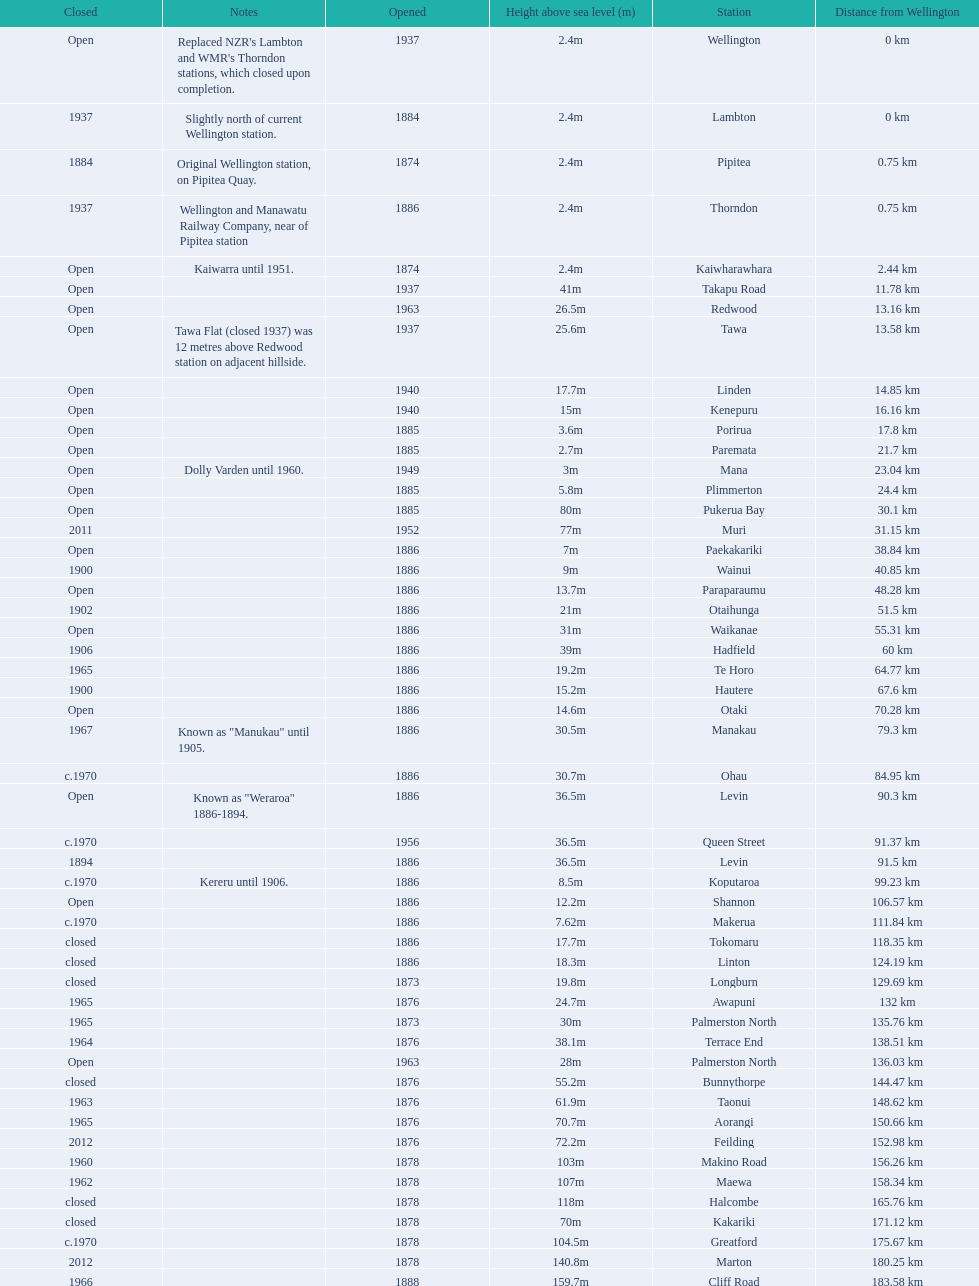How much higher is the takapu road station than the wellington station? 38.6m. 